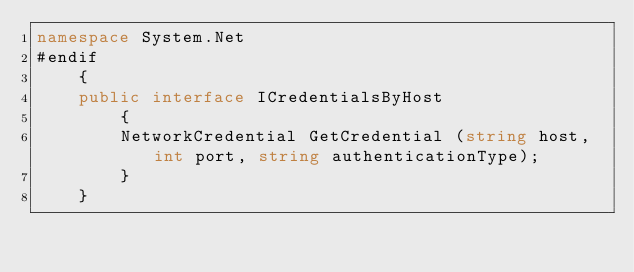Convert code to text. <code><loc_0><loc_0><loc_500><loc_500><_C#_>namespace System.Net
#endif
	{
	public interface ICredentialsByHost
		{
		NetworkCredential GetCredential (string host, int port, string authenticationType);
		}
	}
</code> 